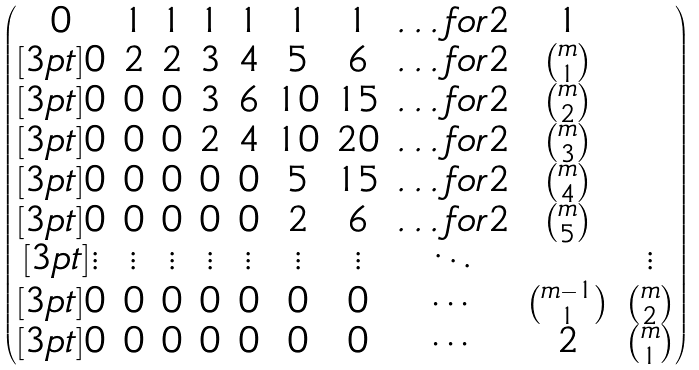<formula> <loc_0><loc_0><loc_500><loc_500>\begin{pmatrix} 0 & 1 & 1 & 1 & 1 & 1 & 1 & \hdots f o r { 2 } & 1 \\ [ 3 p t ] 0 & 2 & 2 & 3 & 4 & 5 & 6 & \hdots f o r { 2 } & \binom { m } { 1 } \\ [ 3 p t ] 0 & 0 & 0 & 3 & 6 & 1 0 & 1 5 & \hdots f o r { 2 } & \binom { m } { 2 } \\ [ 3 p t ] 0 & 0 & 0 & 2 & 4 & 1 0 & 2 0 & \hdots f o r { 2 } & \binom { m } { 3 } \\ [ 3 p t ] 0 & 0 & 0 & 0 & 0 & 5 & 1 5 & \hdots f o r { 2 } & \binom { m } { 4 } \\ [ 3 p t ] 0 & 0 & 0 & 0 & 0 & 2 & 6 & \hdots f o r { 2 } & \binom { m } { 5 } \\ [ 3 p t ] \vdots & \vdots & \vdots & \vdots & \vdots & \vdots & \vdots & \ddots & & \vdots \\ [ 3 p t ] 0 & 0 & 0 & 0 & 0 & 0 & 0 & \cdots & \binom { m - 1 } 1 & \binom { m } { 2 } \\ [ 3 p t ] 0 & 0 & 0 & 0 & 0 & 0 & 0 & \cdots & 2 & \binom { m } { 1 } \end{pmatrix}</formula> 